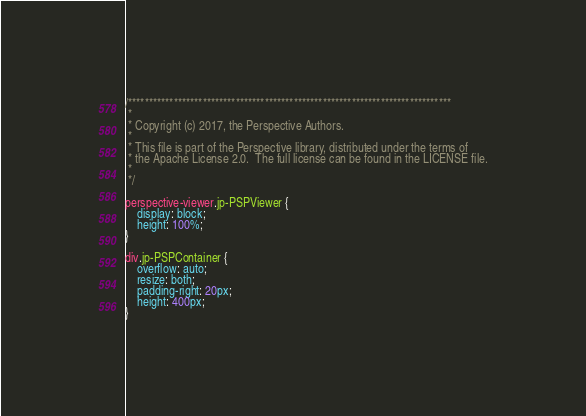Convert code to text. <code><loc_0><loc_0><loc_500><loc_500><_CSS_>/******************************************************************************
 *
 * Copyright (c) 2017, the Perspective Authors.
 *
 * This file is part of the Perspective library, distributed under the terms of
 * the Apache License 2.0.  The full license can be found in the LICENSE file.
 *
 */

perspective-viewer.jp-PSPViewer {
    display: block;
    height: 100%;
}

div.jp-PSPContainer {
    overflow: auto;
    resize: both;
    padding-right: 20px;
    height: 400px;
}</code> 